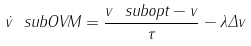Convert formula to latex. <formula><loc_0><loc_0><loc_500><loc_500>\dot { v } \ s u b { O V M } = \frac { v \ s u b { o p t } - v } { \tau } - \lambda \Delta v</formula> 